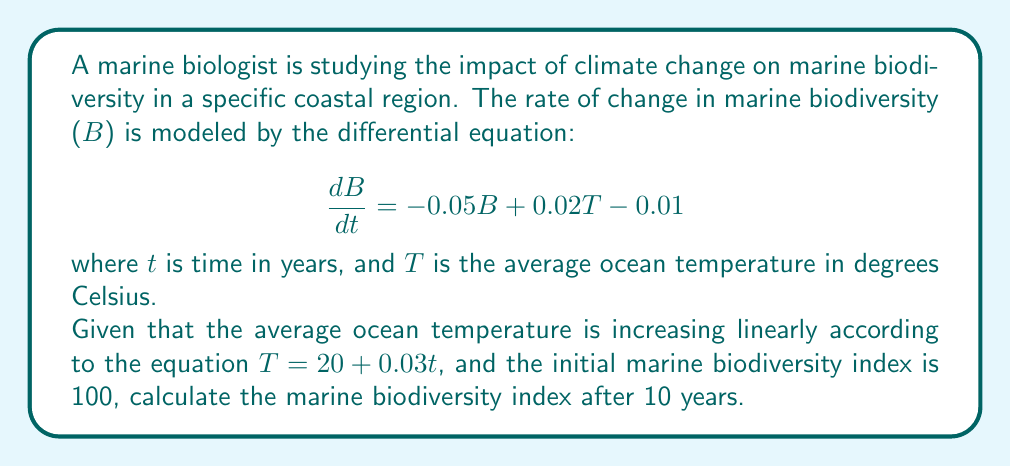What is the answer to this math problem? To solve this problem, we need to follow these steps:

1) First, let's substitute the equation for temperature into our differential equation:

   $$\frac{dB}{dt} = -0.05B + 0.02(20 + 0.03t) - 0.01$$

2) Simplify:

   $$\frac{dB}{dt} = -0.05B + 0.4 + 0.0006t - 0.01$$
   $$\frac{dB}{dt} = -0.05B + 0.39 + 0.0006t$$

3) This is a first-order linear differential equation of the form:

   $$\frac{dB}{dt} + 0.05B = 0.39 + 0.0006t$$

4) The general solution to this type of equation is:

   $$B = e^{-0.05t} \left( \int (0.39 + 0.0006t) e^{0.05t} dt + C \right)$$

5) Solve the integral:

   $$\int (0.39 + 0.0006t) e^{0.05t} dt = \frac{0.39}{0.05}e^{0.05t} + \frac{0.0006}{0.05^2}e^{0.05t} - \frac{0.0006}{0.05}te^{0.05t}$$

6) Substitute back into the general solution:

   $$B = e^{-0.05t} \left( \frac{0.39}{0.05}e^{0.05t} + \frac{0.0006}{0.05^2}e^{0.05t} - \frac{0.0006}{0.05}te^{0.05t} + C \right)$$

7) Simplify:

   $$B = 7.8 + 0.24 - 0.012t + Ce^{-0.05t}$$

8) Use the initial condition $B(0) = 100$ to find $C$:

   $$100 = 7.8 + 0.24 + C$$
   $$C = 91.96$$

9) Therefore, the particular solution is:

   $$B = 8.04 - 0.012t + 91.96e^{-0.05t}$$

10) To find $B$ after 10 years, substitute $t = 10$:

    $$B(10) = 8.04 - 0.012(10) + 91.96e^{-0.05(10)}$$
    $$B(10) = 7.92 + 91.96e^{-0.5}$$
    $$B(10) = 7.92 + 56.39$$
    $$B(10) = 64.31$$
Answer: The marine biodiversity index after 10 years is approximately 64.31. 